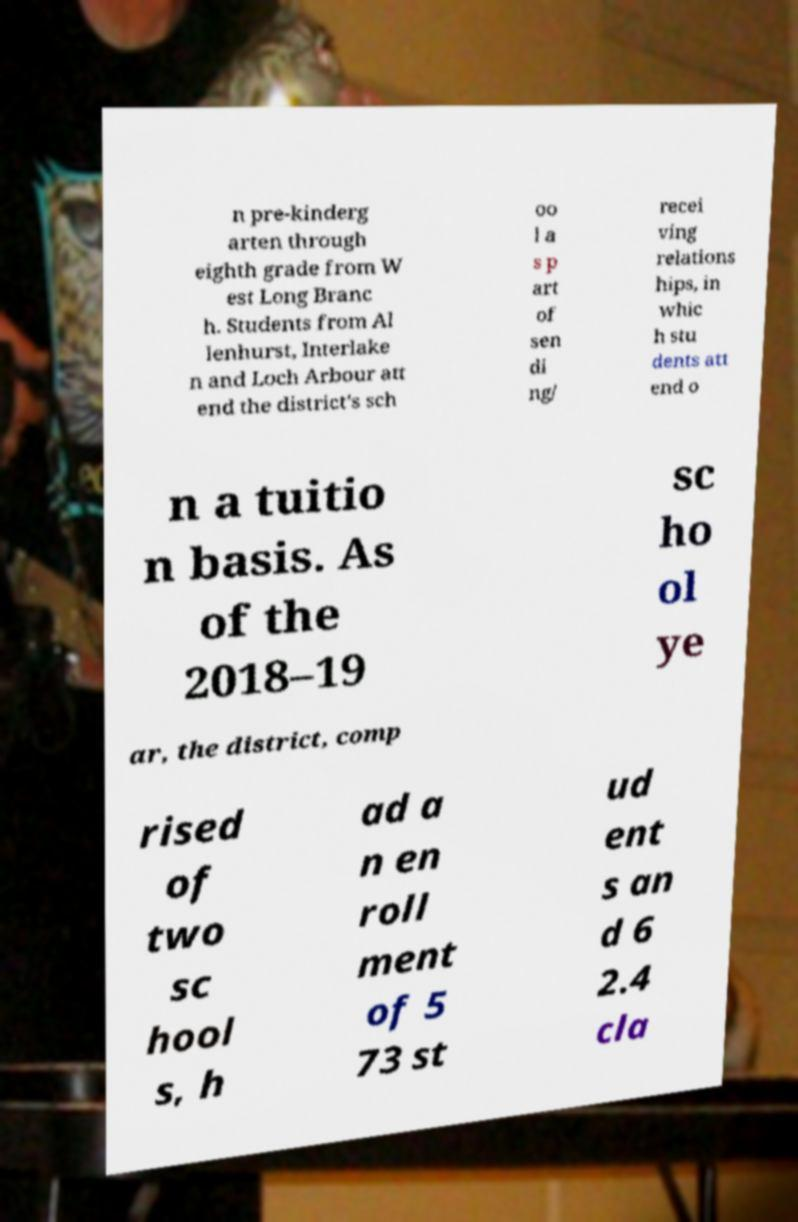Can you read and provide the text displayed in the image?This photo seems to have some interesting text. Can you extract and type it out for me? n pre-kinderg arten through eighth grade from W est Long Branc h. Students from Al lenhurst, Interlake n and Loch Arbour att end the district's sch oo l a s p art of sen di ng/ recei ving relations hips, in whic h stu dents att end o n a tuitio n basis. As of the 2018–19 sc ho ol ye ar, the district, comp rised of two sc hool s, h ad a n en roll ment of 5 73 st ud ent s an d 6 2.4 cla 